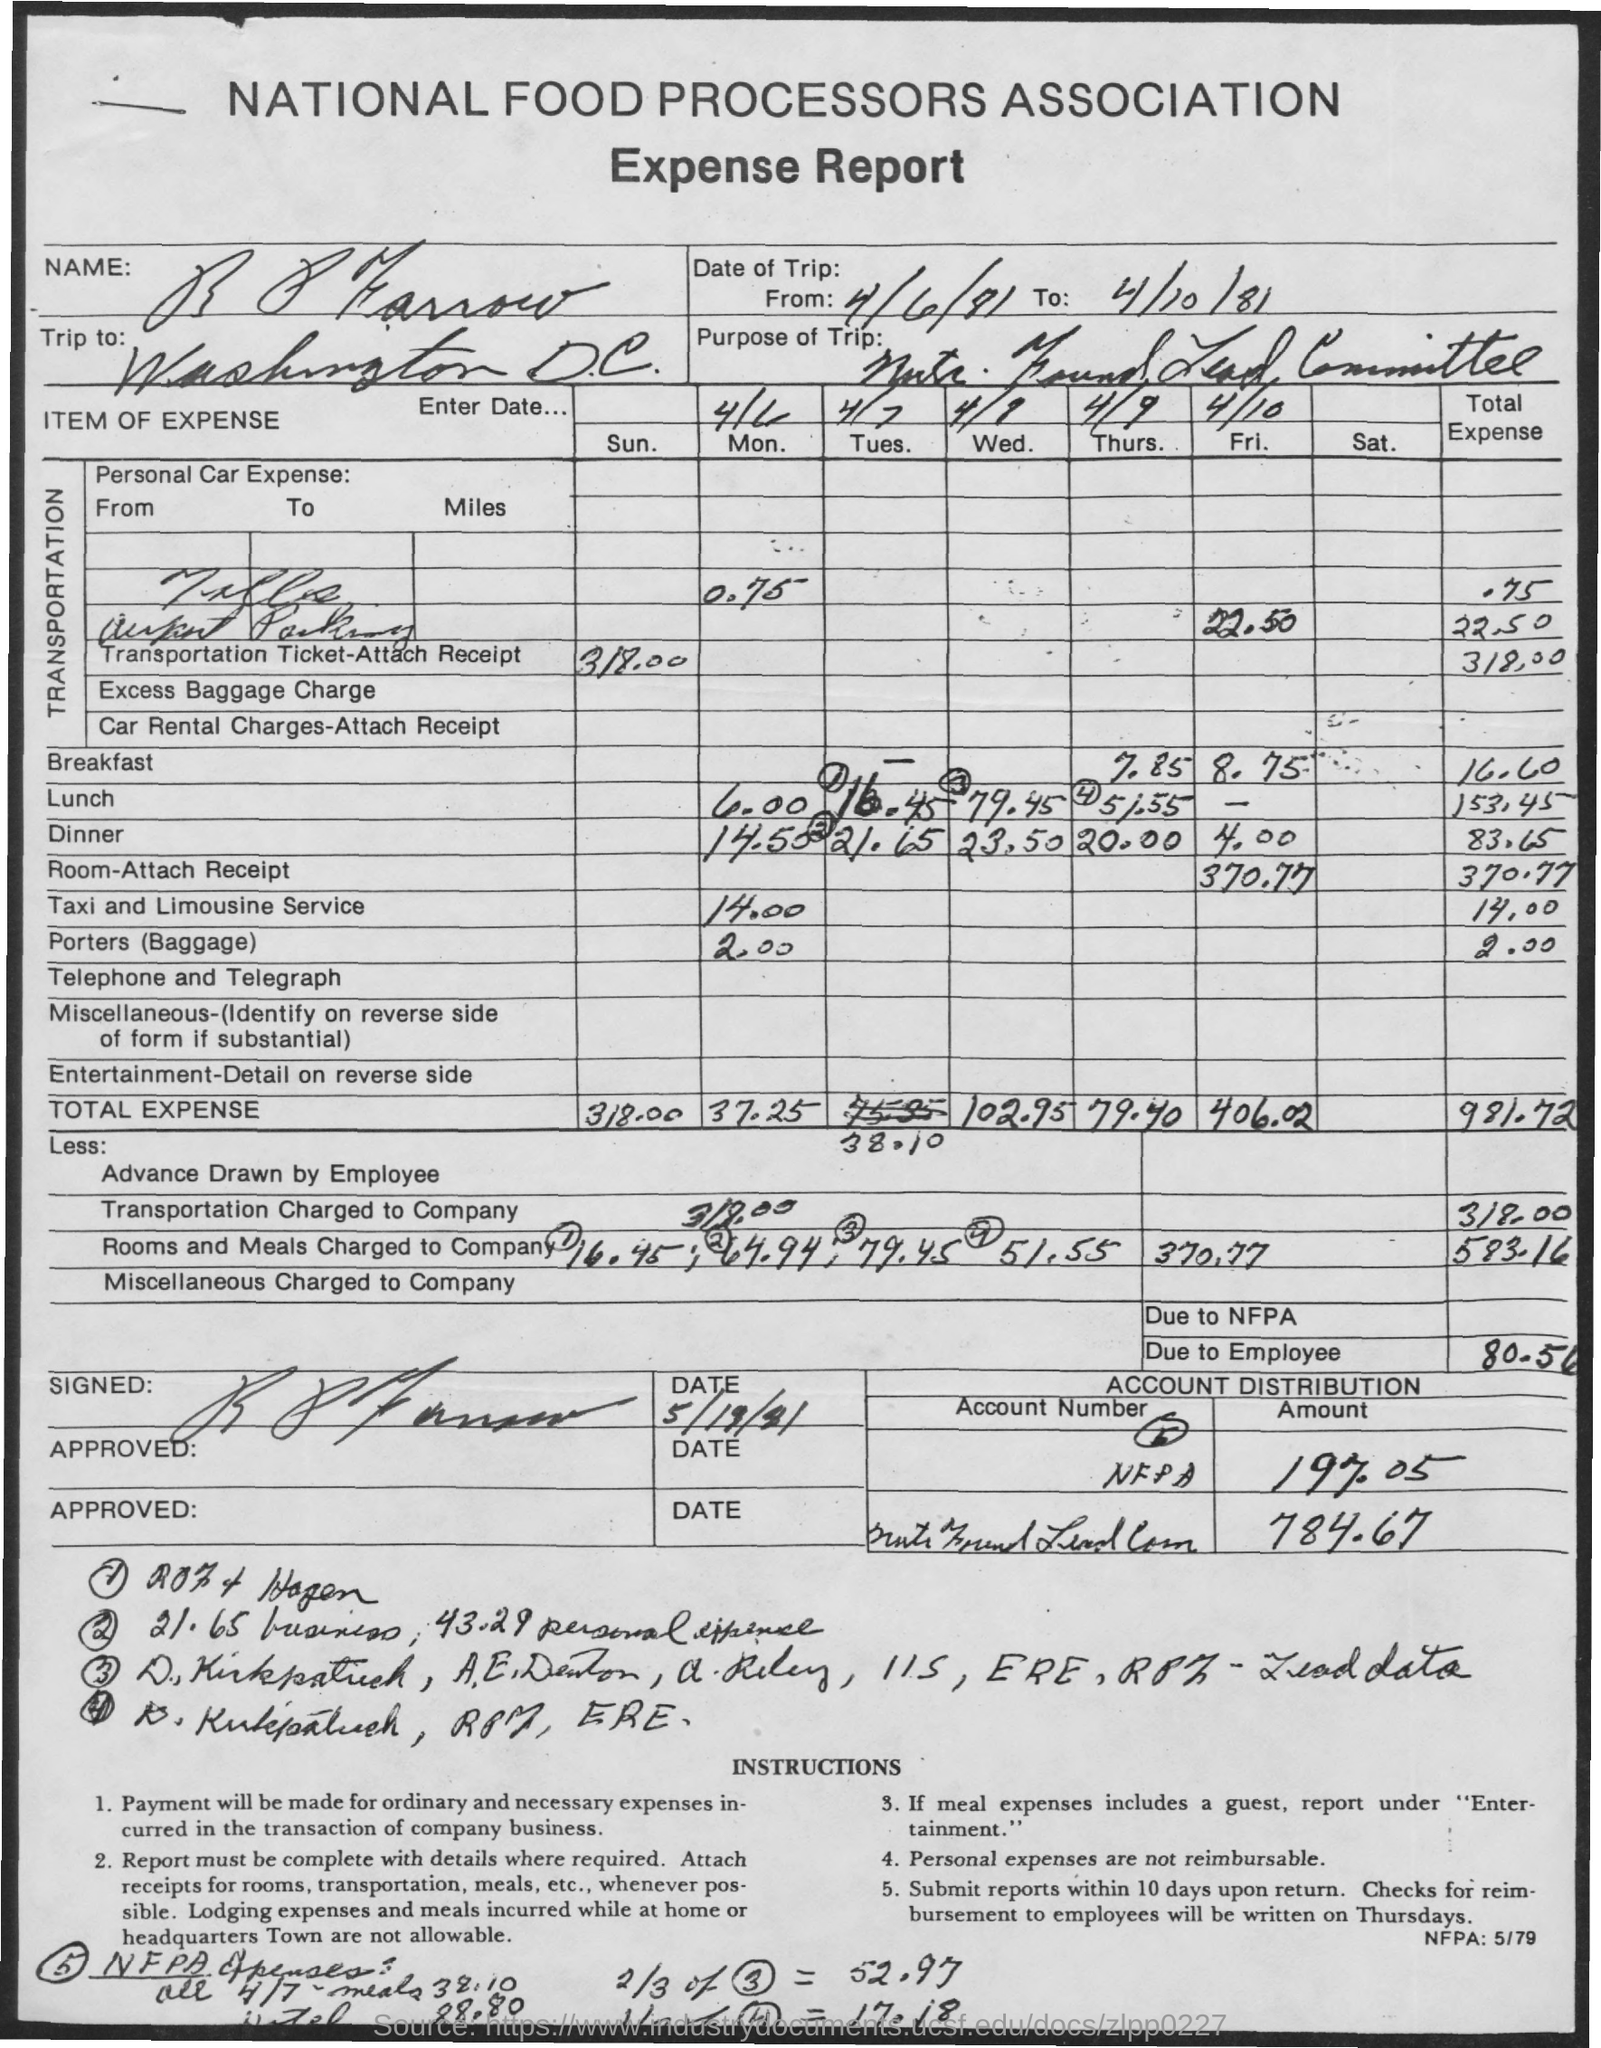What is the first title in the document?
Your response must be concise. National Food Processors Association. What is the second title in the document?
Provide a short and direct response. Expense Report. What is the total expense for breakfast?
Make the answer very short. 16.60. What is the total expense for the taxi and limousine service?
Keep it short and to the point. 14.00. The trip is to which place?
Keep it short and to the point. Washington d.c. What is the total expense on Sunday?
Offer a very short reply. 318.00. What is due to the employee?
Ensure brevity in your answer.  80.56. 